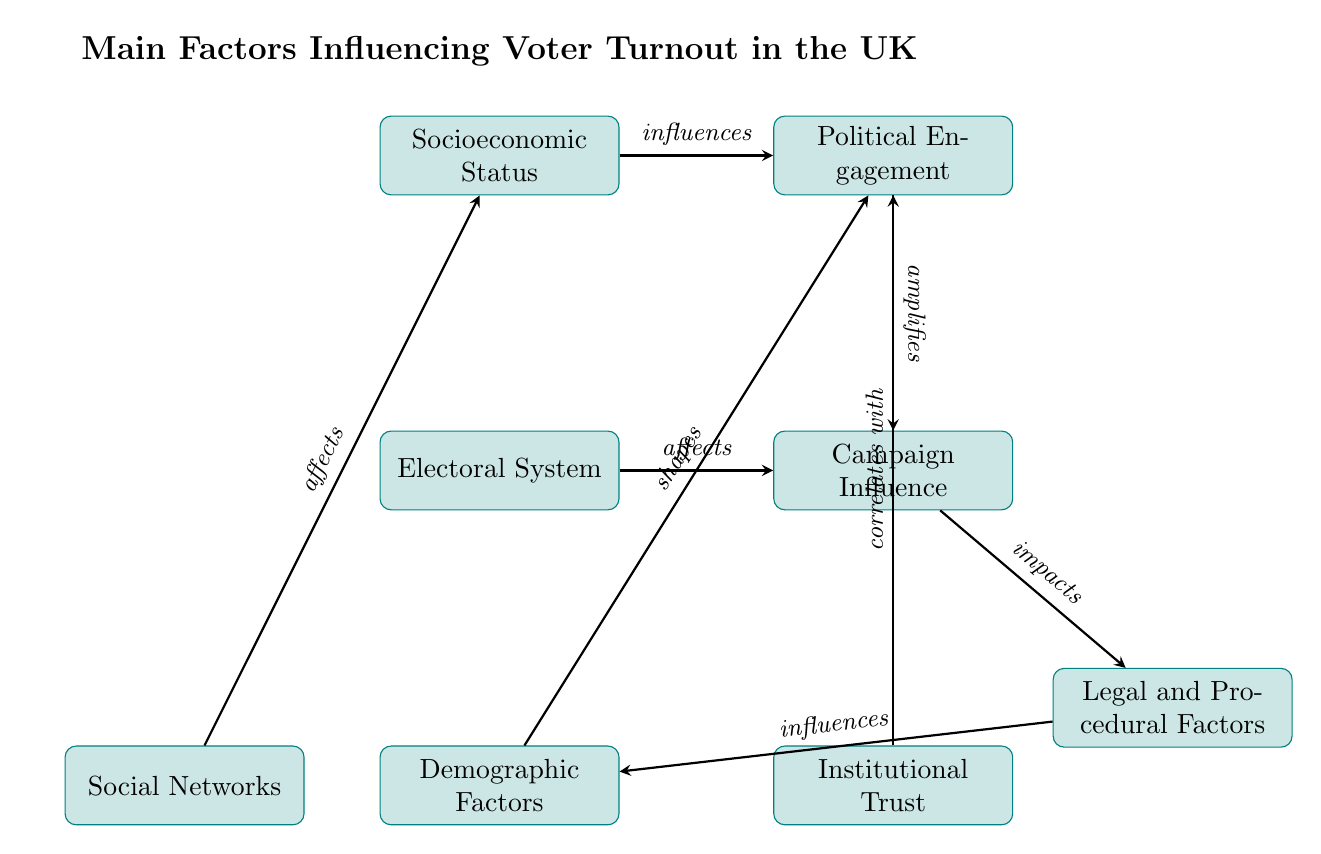What is the total number of nodes in the diagram? The diagram lists eight different factors that influence voter turnout, which are represented as nodes. Counting these factors, we confirm there are eight nodes in total.
Answer: 8 Which factor influences Political Engagement? According to the diagram, Socioeconomic Status is shown to influence Political Engagement. This is indicated by a directed arrow going from the node "Socioeconomic Status" to the node "Political Engagement".
Answer: Socioeconomic Status What relationship does the Electoral System have with Campaign Influence? The diagram indicates that the Electoral System affects Campaign Influence. This relationship is depicted by the arrow pointing from the Electoral System node directly to the Campaign Influence node.
Answer: affects How many factors directly influence Demographic Factors? Looking at the diagram, we see that only one factor, Legal and Procedural Factors, points to Demographic Factors, indicating that it is the only factor influencing it specifically in this flow.
Answer: 1 What influences Institutional Trust according to the diagram? The diagram shows that there is a correlation between Institutional Trust and Political Engagement, as indicated by the arrow leading from Institutional Trust to Political Engagement. Thus, Institutional Trust correlates with Political Engagement.
Answer: Political Engagement Which two factors are found below the Electoral System in the diagram? The diagram places Demographic Factors directly below the Electoral System, and to the right of it is Campaign Influence. This positioning defines their locations relative to the Electoral System node.
Answer: Demographic Factors, Campaign Influence How does Campaign Influence impact Legal and Procedural Factors? The diagram clearly states that Campaign Influence impacts Legal and Procedural Factors through an arrow indicating the relationship from Campaign Influence to Legal and Procedural Factors. This means that effective campaigns can affect the laws and procedures related to voting.
Answer: impacts Which factor correlates with Political Engagement aside from Socioeconomic Status? The only other factor that correlates with Political Engagement in the diagram is Institutional Trust; hence both are linked to enrich the understanding of Political Engagement.
Answer: Institutional Trust 